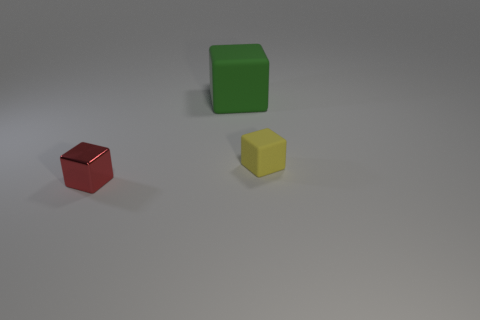Add 1 cyan rubber cylinders. How many objects exist? 4 Subtract all tiny cyan cylinders. Subtract all tiny red metallic blocks. How many objects are left? 2 Add 3 small metal cubes. How many small metal cubes are left? 4 Add 1 tiny matte things. How many tiny matte things exist? 2 Subtract 0 gray cubes. How many objects are left? 3 